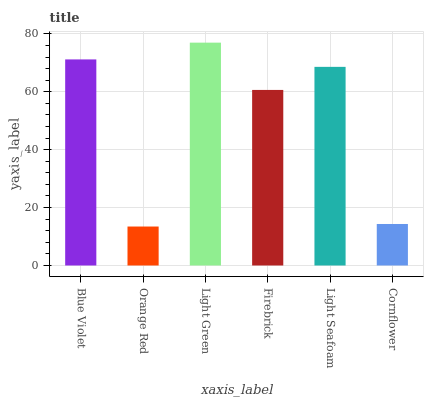Is Orange Red the minimum?
Answer yes or no. Yes. Is Light Green the maximum?
Answer yes or no. Yes. Is Light Green the minimum?
Answer yes or no. No. Is Orange Red the maximum?
Answer yes or no. No. Is Light Green greater than Orange Red?
Answer yes or no. Yes. Is Orange Red less than Light Green?
Answer yes or no. Yes. Is Orange Red greater than Light Green?
Answer yes or no. No. Is Light Green less than Orange Red?
Answer yes or no. No. Is Light Seafoam the high median?
Answer yes or no. Yes. Is Firebrick the low median?
Answer yes or no. Yes. Is Orange Red the high median?
Answer yes or no. No. Is Orange Red the low median?
Answer yes or no. No. 